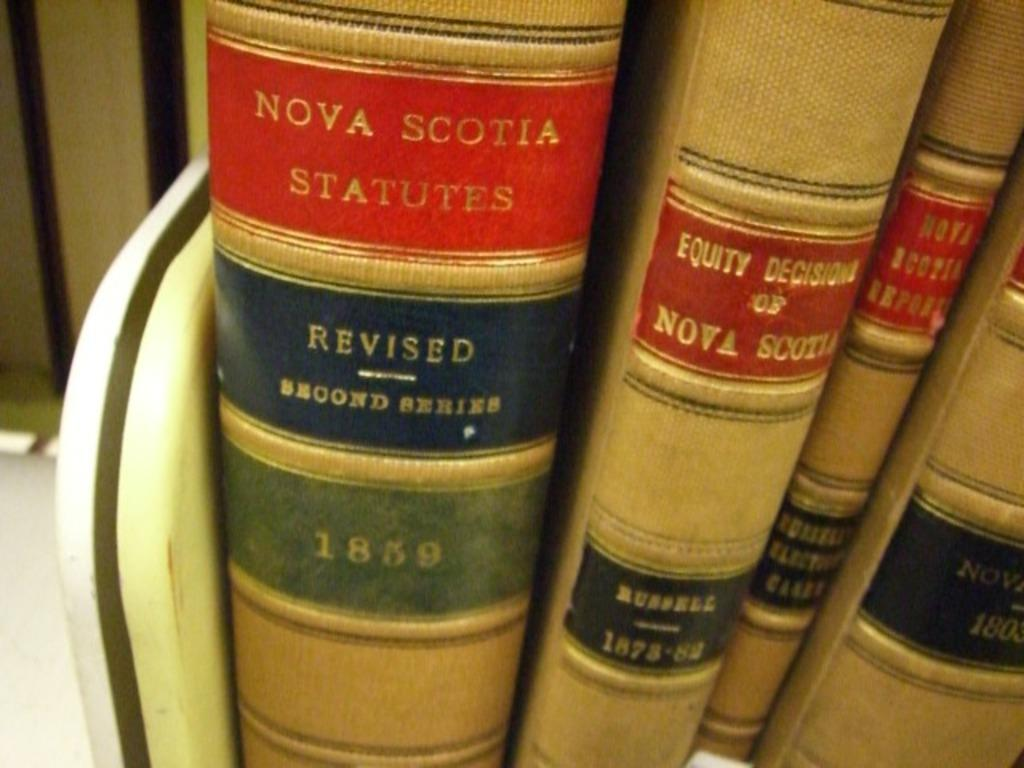<image>
Provide a brief description of the given image. A close-up of the spines of several books about Nova Scotia. 